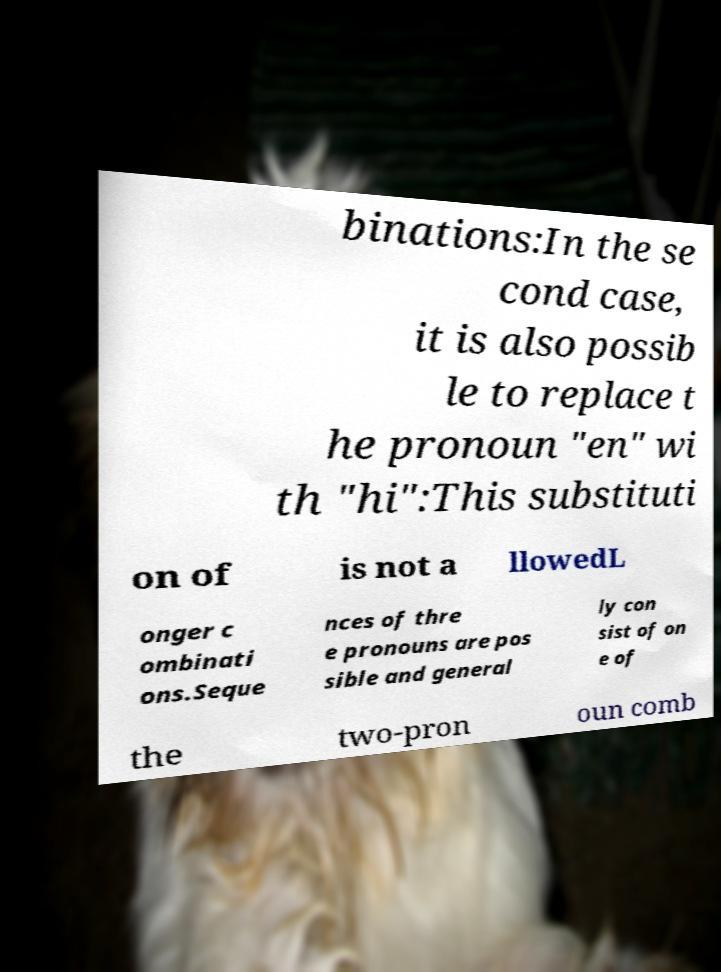Could you assist in decoding the text presented in this image and type it out clearly? binations:In the se cond case, it is also possib le to replace t he pronoun "en" wi th "hi":This substituti on of is not a llowedL onger c ombinati ons.Seque nces of thre e pronouns are pos sible and general ly con sist of on e of the two-pron oun comb 